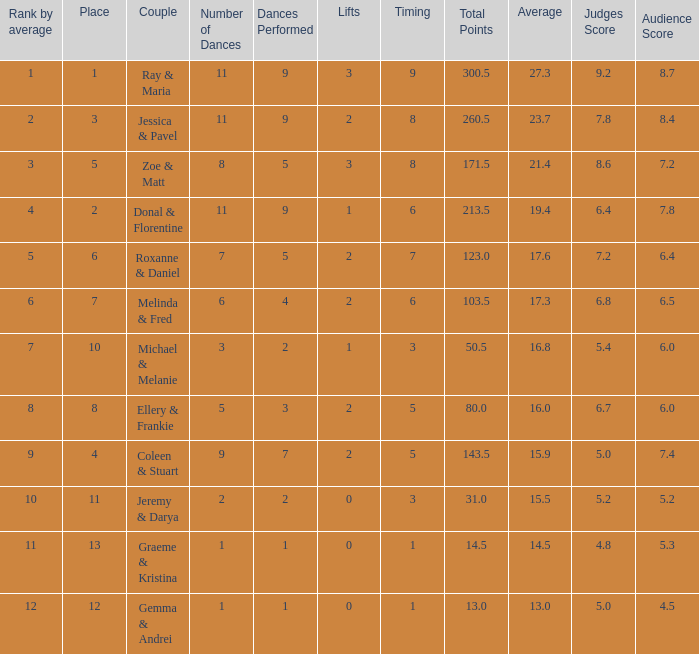If your rank by average is 9, what is the name of the couple? Coleen & Stuart. 